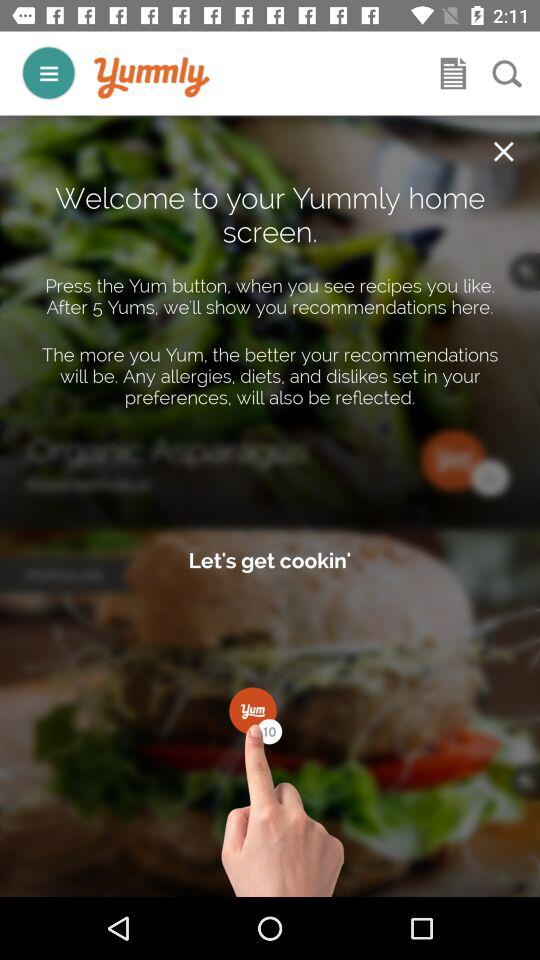What is the app name? The app name is "Yummly". 